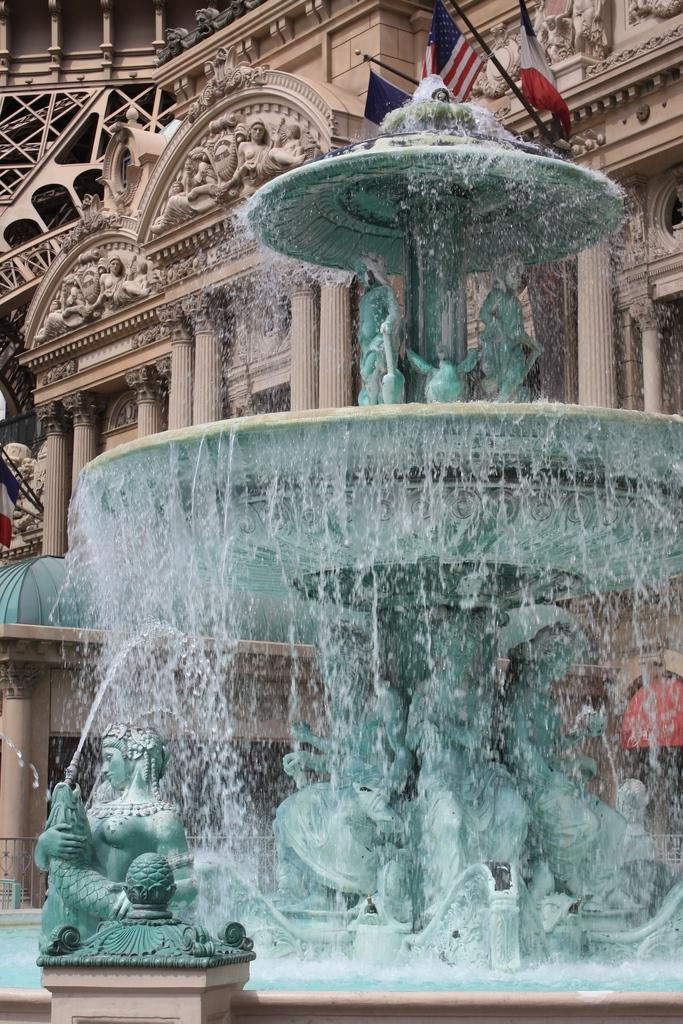What is the main feature in the image? There is a fountain in the image. What other objects or structures can be seen in the image? There are sculptures and a building with pillars in the image. Are there any sculptures on the building? Yes, there are sculptures on the building. What decorative elements are present on the building? There are flags on the building. What type of stove can be seen in the image? There is no stove present in the image. How many legs does the whip have in the image? There is no whip present in the image. 